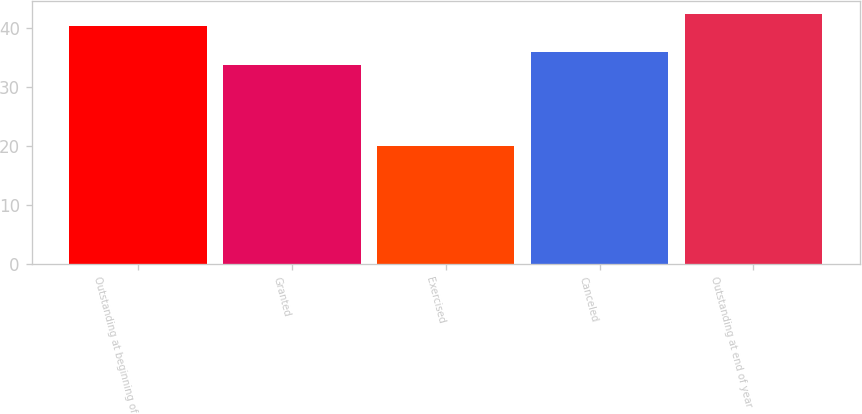Convert chart. <chart><loc_0><loc_0><loc_500><loc_500><bar_chart><fcel>Outstanding at beginning of<fcel>Granted<fcel>Exercised<fcel>Canceled<fcel>Outstanding at end of year<nl><fcel>40.36<fcel>33.77<fcel>19.92<fcel>35.86<fcel>42.45<nl></chart> 